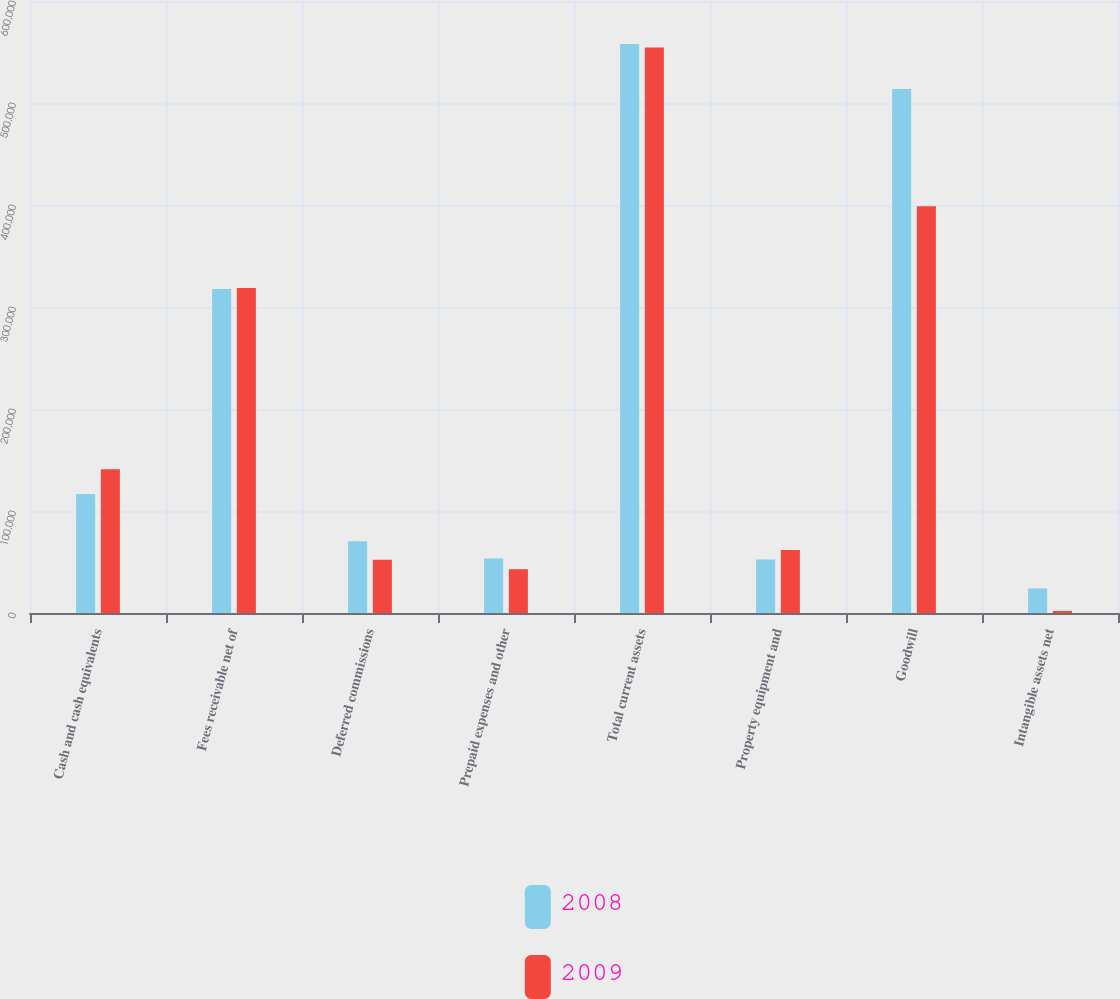Convert chart to OTSL. <chart><loc_0><loc_0><loc_500><loc_500><stacked_bar_chart><ecel><fcel>Cash and cash equivalents<fcel>Fees receivable net of<fcel>Deferred commissions<fcel>Prepaid expenses and other<fcel>Total current assets<fcel>Property equipment and<fcel>Goodwill<fcel>Intangible assets net<nl><fcel>2008<fcel>116574<fcel>317598<fcel>70253<fcel>53400<fcel>557825<fcel>52466<fcel>513612<fcel>24113<nl><fcel>2009<fcel>140929<fcel>318511<fcel>52149<fcel>42935<fcel>554524<fcel>61869<fcel>398737<fcel>2015<nl></chart> 